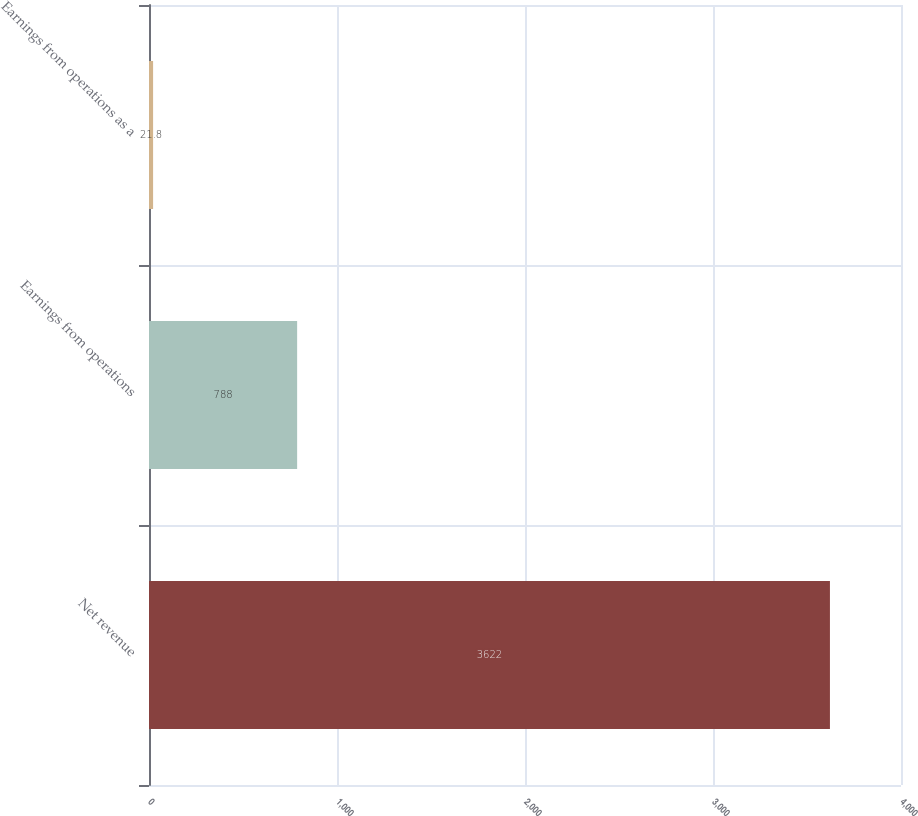Convert chart. <chart><loc_0><loc_0><loc_500><loc_500><bar_chart><fcel>Net revenue<fcel>Earnings from operations<fcel>Earnings from operations as a<nl><fcel>3622<fcel>788<fcel>21.8<nl></chart> 